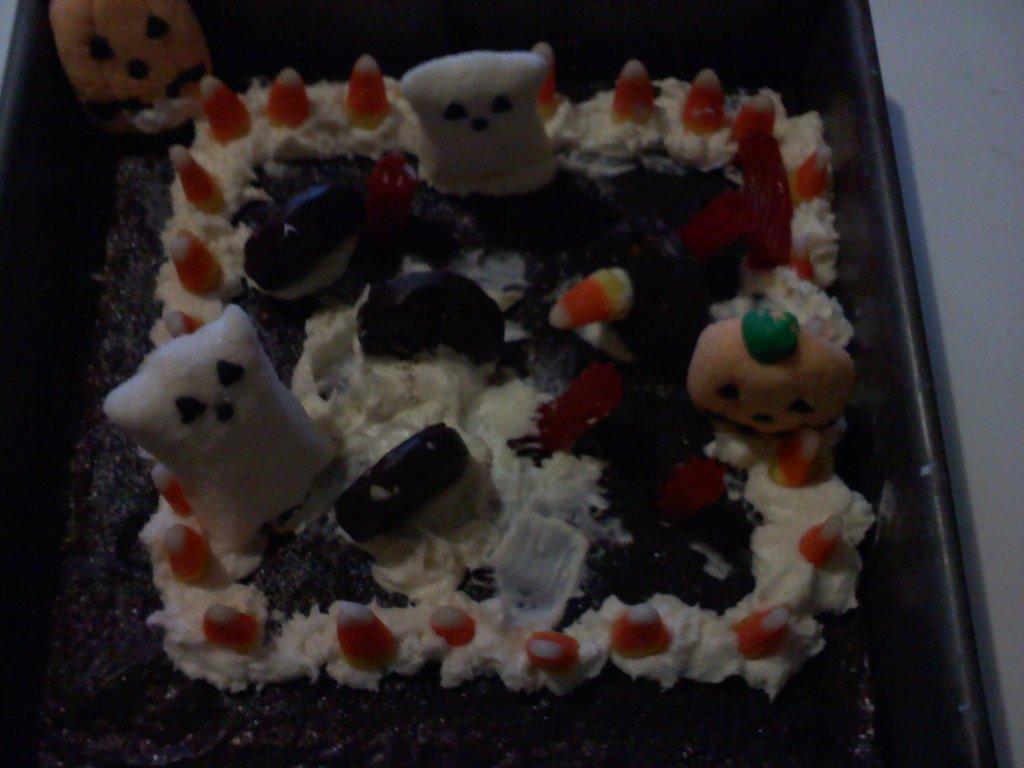Could you give a brief overview of what you see in this image? In this picture we can see cake and toys in a container and we can see wall. 